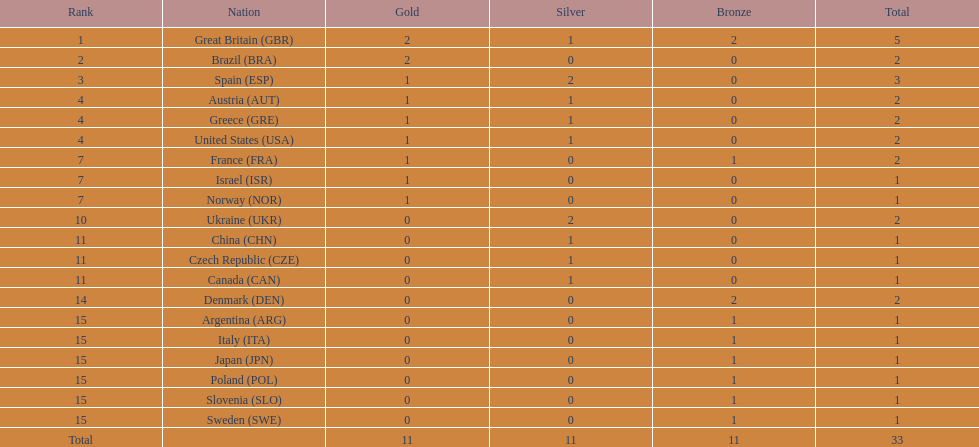What nation was next to great britain in total medal count? Spain. 